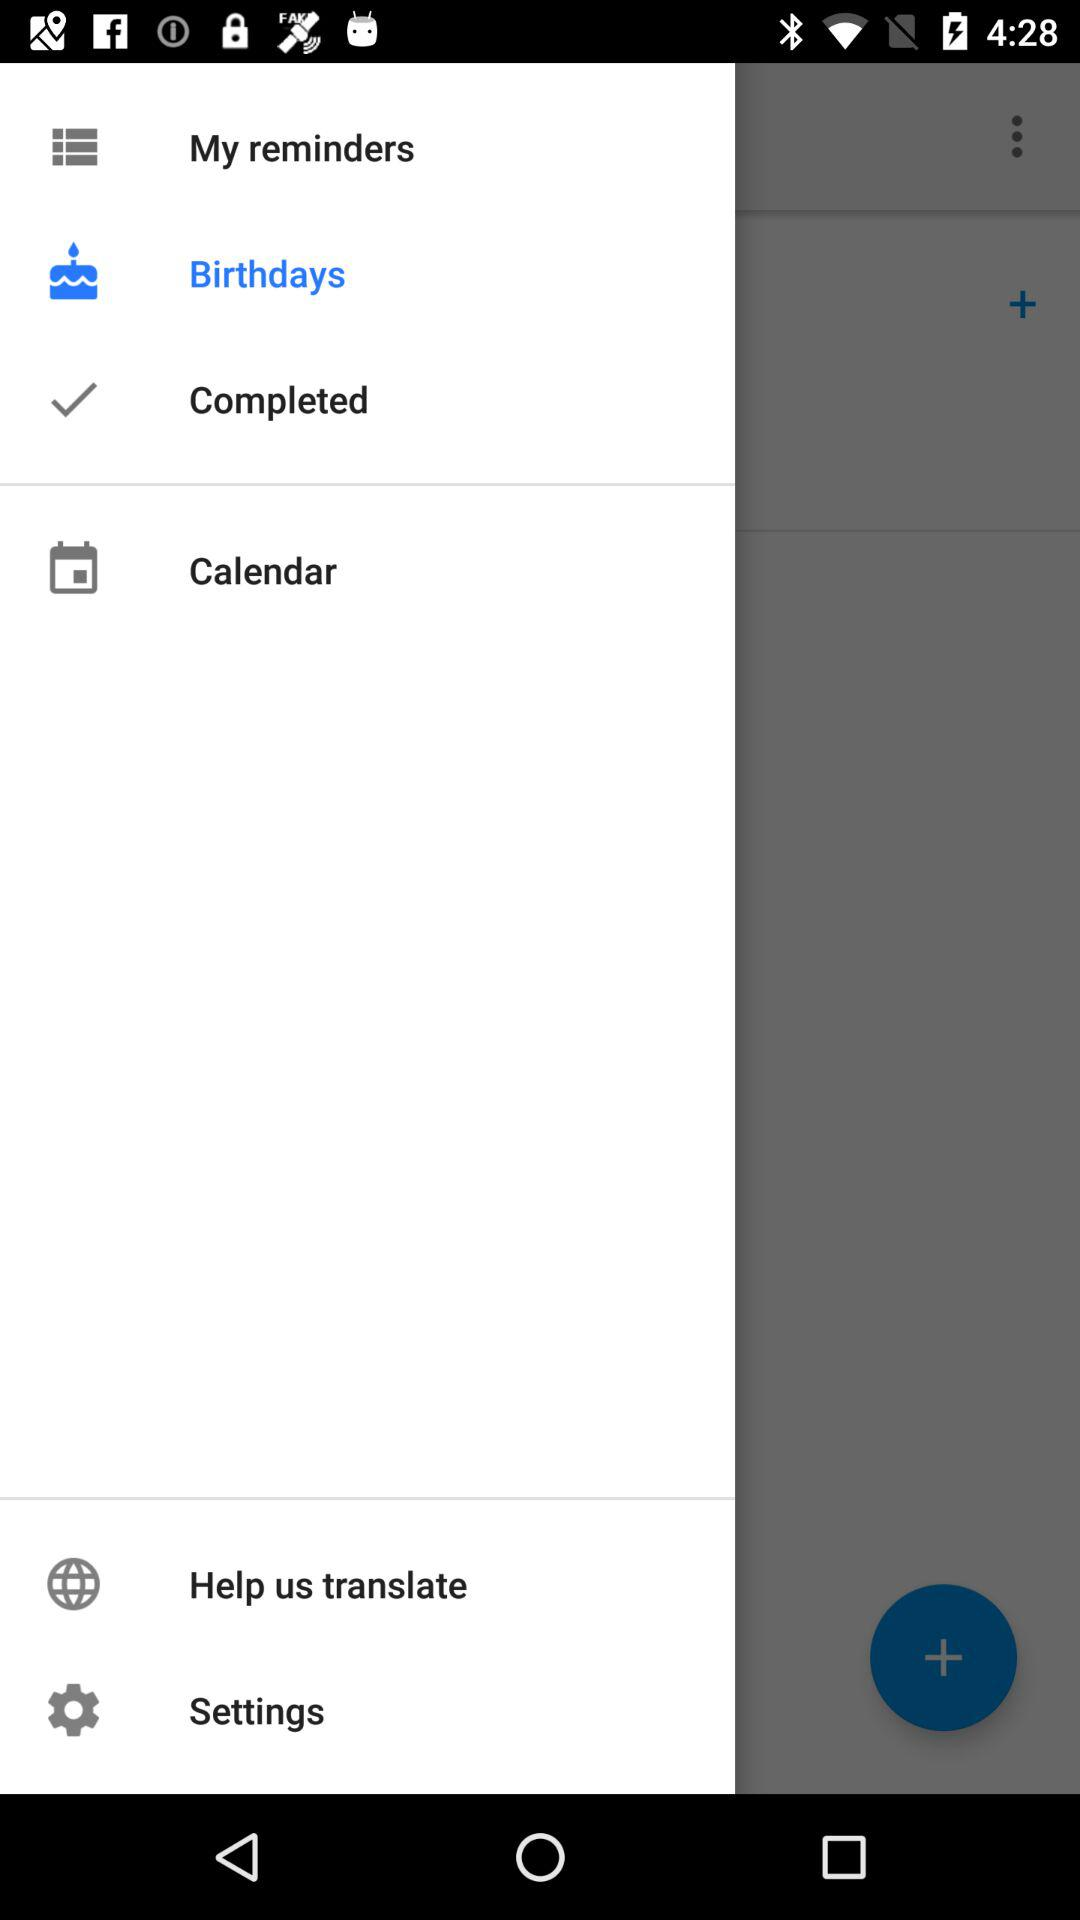Which is the selected option? The selected option is "Birthdays". 